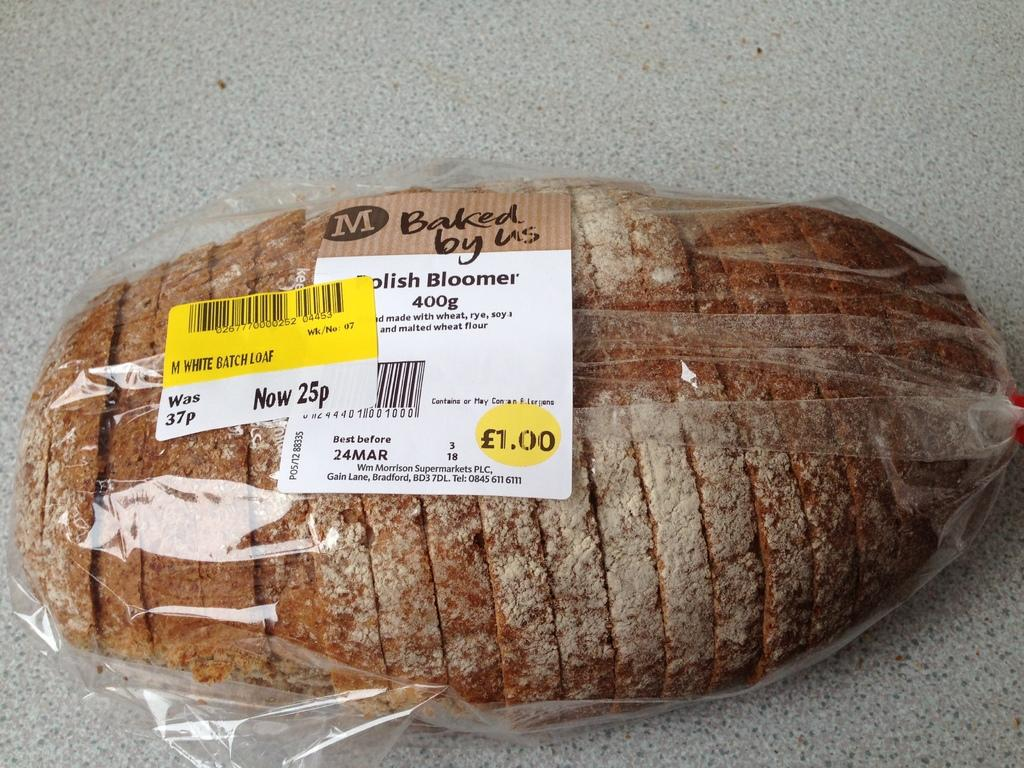What is contained within the packet in the image? There is food in the packet in the image. Where is the packet located? The packet is on a surface in the image. What additional features are present on the packet? There are stickers on the packet in the image. What thoughts or beliefs are expressed by the packet in the image? The packet in the image does not express any thoughts or beliefs, as it is an inanimate object. 